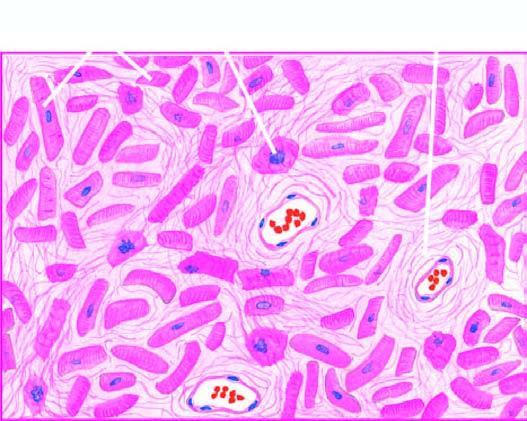s an intimal patchy myocardial fibrosis, especially around small blood vessels in the interstitium?
Answer the question using a single word or phrase. No 